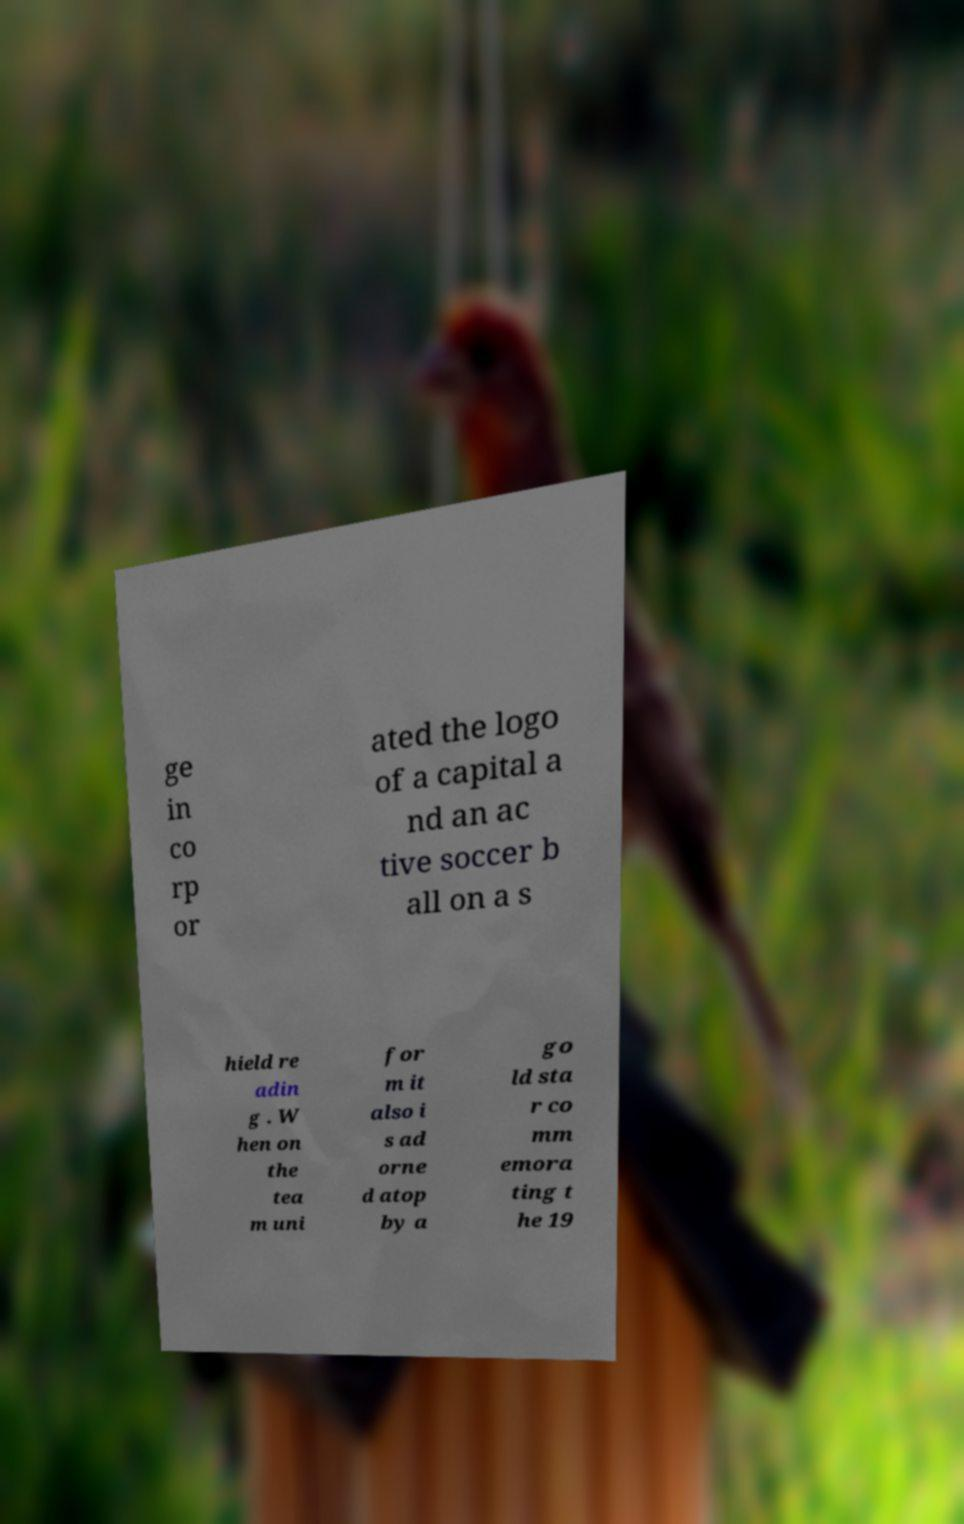For documentation purposes, I need the text within this image transcribed. Could you provide that? ge in co rp or ated the logo of a capital a nd an ac tive soccer b all on a s hield re adin g . W hen on the tea m uni for m it also i s ad orne d atop by a go ld sta r co mm emora ting t he 19 